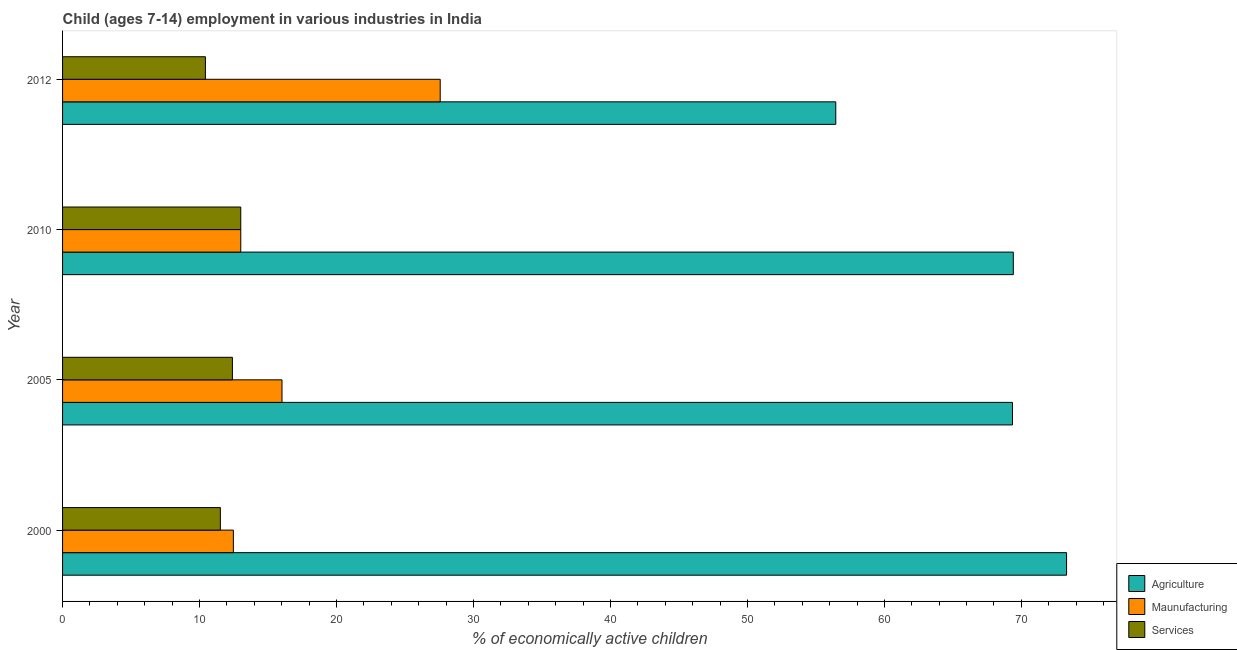Are the number of bars on each tick of the Y-axis equal?
Provide a short and direct response. Yes. How many bars are there on the 1st tick from the bottom?
Your answer should be compact. 3. What is the label of the 1st group of bars from the top?
Provide a short and direct response. 2012. In how many cases, is the number of bars for a given year not equal to the number of legend labels?
Provide a succinct answer. 0. What is the percentage of economically active children in manufacturing in 2010?
Provide a short and direct response. 13.01. Across all years, what is the maximum percentage of economically active children in services?
Offer a very short reply. 13.01. Across all years, what is the minimum percentage of economically active children in services?
Keep it short and to the point. 10.43. What is the total percentage of economically active children in agriculture in the graph?
Keep it short and to the point. 268.51. What is the difference between the percentage of economically active children in services in 2005 and that in 2010?
Provide a succinct answer. -0.61. What is the difference between the percentage of economically active children in agriculture in 2010 and the percentage of economically active children in manufacturing in 2005?
Offer a very short reply. 53.39. What is the average percentage of economically active children in services per year?
Ensure brevity in your answer.  11.84. In the year 2010, what is the difference between the percentage of economically active children in agriculture and percentage of economically active children in services?
Offer a very short reply. 56.4. In how many years, is the percentage of economically active children in manufacturing greater than 68 %?
Your response must be concise. 0. What is the ratio of the percentage of economically active children in manufacturing in 2000 to that in 2005?
Provide a succinct answer. 0.78. Is the difference between the percentage of economically active children in services in 2000 and 2012 greater than the difference between the percentage of economically active children in manufacturing in 2000 and 2012?
Offer a very short reply. Yes. What is the difference between the highest and the second highest percentage of economically active children in agriculture?
Your response must be concise. 3.89. What is the difference between the highest and the lowest percentage of economically active children in services?
Your response must be concise. 2.58. In how many years, is the percentage of economically active children in manufacturing greater than the average percentage of economically active children in manufacturing taken over all years?
Your answer should be very brief. 1. Is the sum of the percentage of economically active children in manufacturing in 2010 and 2012 greater than the maximum percentage of economically active children in agriculture across all years?
Keep it short and to the point. No. What does the 2nd bar from the top in 2000 represents?
Your response must be concise. Maunufacturing. What does the 3rd bar from the bottom in 2010 represents?
Your response must be concise. Services. Is it the case that in every year, the sum of the percentage of economically active children in agriculture and percentage of economically active children in manufacturing is greater than the percentage of economically active children in services?
Your response must be concise. Yes. How many bars are there?
Make the answer very short. 12. Does the graph contain any zero values?
Provide a short and direct response. No. Does the graph contain grids?
Offer a very short reply. No. Where does the legend appear in the graph?
Ensure brevity in your answer.  Bottom right. How are the legend labels stacked?
Provide a short and direct response. Vertical. What is the title of the graph?
Give a very brief answer. Child (ages 7-14) employment in various industries in India. Does "Social Protection" appear as one of the legend labels in the graph?
Give a very brief answer. No. What is the label or title of the X-axis?
Offer a terse response. % of economically active children. What is the % of economically active children in Agriculture in 2000?
Provide a succinct answer. 73.3. What is the % of economically active children in Maunufacturing in 2000?
Offer a very short reply. 12.47. What is the % of economically active children in Services in 2000?
Provide a short and direct response. 11.52. What is the % of economically active children of Agriculture in 2005?
Your answer should be very brief. 69.35. What is the % of economically active children of Maunufacturing in 2005?
Offer a very short reply. 16.02. What is the % of economically active children in Agriculture in 2010?
Your response must be concise. 69.41. What is the % of economically active children in Maunufacturing in 2010?
Your response must be concise. 13.01. What is the % of economically active children in Services in 2010?
Offer a very short reply. 13.01. What is the % of economically active children in Agriculture in 2012?
Ensure brevity in your answer.  56.45. What is the % of economically active children of Maunufacturing in 2012?
Provide a short and direct response. 27.57. What is the % of economically active children of Services in 2012?
Your response must be concise. 10.43. Across all years, what is the maximum % of economically active children of Agriculture?
Ensure brevity in your answer.  73.3. Across all years, what is the maximum % of economically active children of Maunufacturing?
Keep it short and to the point. 27.57. Across all years, what is the maximum % of economically active children of Services?
Offer a very short reply. 13.01. Across all years, what is the minimum % of economically active children in Agriculture?
Your response must be concise. 56.45. Across all years, what is the minimum % of economically active children of Maunufacturing?
Provide a short and direct response. 12.47. Across all years, what is the minimum % of economically active children of Services?
Your response must be concise. 10.43. What is the total % of economically active children in Agriculture in the graph?
Provide a short and direct response. 268.51. What is the total % of economically active children of Maunufacturing in the graph?
Your response must be concise. 69.07. What is the total % of economically active children of Services in the graph?
Your answer should be compact. 47.36. What is the difference between the % of economically active children in Agriculture in 2000 and that in 2005?
Your response must be concise. 3.95. What is the difference between the % of economically active children of Maunufacturing in 2000 and that in 2005?
Your answer should be compact. -3.55. What is the difference between the % of economically active children of Services in 2000 and that in 2005?
Keep it short and to the point. -0.88. What is the difference between the % of economically active children in Agriculture in 2000 and that in 2010?
Your response must be concise. 3.89. What is the difference between the % of economically active children of Maunufacturing in 2000 and that in 2010?
Your answer should be compact. -0.54. What is the difference between the % of economically active children of Services in 2000 and that in 2010?
Make the answer very short. -1.49. What is the difference between the % of economically active children in Agriculture in 2000 and that in 2012?
Your answer should be compact. 16.85. What is the difference between the % of economically active children in Maunufacturing in 2000 and that in 2012?
Give a very brief answer. -15.1. What is the difference between the % of economically active children in Services in 2000 and that in 2012?
Provide a short and direct response. 1.09. What is the difference between the % of economically active children of Agriculture in 2005 and that in 2010?
Provide a short and direct response. -0.06. What is the difference between the % of economically active children of Maunufacturing in 2005 and that in 2010?
Give a very brief answer. 3.01. What is the difference between the % of economically active children of Services in 2005 and that in 2010?
Make the answer very short. -0.61. What is the difference between the % of economically active children of Agriculture in 2005 and that in 2012?
Your answer should be very brief. 12.9. What is the difference between the % of economically active children in Maunufacturing in 2005 and that in 2012?
Provide a short and direct response. -11.55. What is the difference between the % of economically active children in Services in 2005 and that in 2012?
Your answer should be compact. 1.97. What is the difference between the % of economically active children in Agriculture in 2010 and that in 2012?
Offer a terse response. 12.96. What is the difference between the % of economically active children in Maunufacturing in 2010 and that in 2012?
Your answer should be compact. -14.56. What is the difference between the % of economically active children of Services in 2010 and that in 2012?
Give a very brief answer. 2.58. What is the difference between the % of economically active children of Agriculture in 2000 and the % of economically active children of Maunufacturing in 2005?
Provide a short and direct response. 57.28. What is the difference between the % of economically active children in Agriculture in 2000 and the % of economically active children in Services in 2005?
Make the answer very short. 60.9. What is the difference between the % of economically active children in Maunufacturing in 2000 and the % of economically active children in Services in 2005?
Make the answer very short. 0.07. What is the difference between the % of economically active children in Agriculture in 2000 and the % of economically active children in Maunufacturing in 2010?
Your answer should be compact. 60.29. What is the difference between the % of economically active children in Agriculture in 2000 and the % of economically active children in Services in 2010?
Give a very brief answer. 60.29. What is the difference between the % of economically active children of Maunufacturing in 2000 and the % of economically active children of Services in 2010?
Ensure brevity in your answer.  -0.54. What is the difference between the % of economically active children in Agriculture in 2000 and the % of economically active children in Maunufacturing in 2012?
Give a very brief answer. 45.73. What is the difference between the % of economically active children in Agriculture in 2000 and the % of economically active children in Services in 2012?
Provide a succinct answer. 62.87. What is the difference between the % of economically active children of Maunufacturing in 2000 and the % of economically active children of Services in 2012?
Offer a very short reply. 2.04. What is the difference between the % of economically active children in Agriculture in 2005 and the % of economically active children in Maunufacturing in 2010?
Your answer should be compact. 56.34. What is the difference between the % of economically active children of Agriculture in 2005 and the % of economically active children of Services in 2010?
Provide a succinct answer. 56.34. What is the difference between the % of economically active children of Maunufacturing in 2005 and the % of economically active children of Services in 2010?
Your response must be concise. 3.01. What is the difference between the % of economically active children in Agriculture in 2005 and the % of economically active children in Maunufacturing in 2012?
Your answer should be compact. 41.78. What is the difference between the % of economically active children of Agriculture in 2005 and the % of economically active children of Services in 2012?
Give a very brief answer. 58.92. What is the difference between the % of economically active children of Maunufacturing in 2005 and the % of economically active children of Services in 2012?
Offer a very short reply. 5.59. What is the difference between the % of economically active children in Agriculture in 2010 and the % of economically active children in Maunufacturing in 2012?
Keep it short and to the point. 41.84. What is the difference between the % of economically active children in Agriculture in 2010 and the % of economically active children in Services in 2012?
Give a very brief answer. 58.98. What is the difference between the % of economically active children of Maunufacturing in 2010 and the % of economically active children of Services in 2012?
Your answer should be compact. 2.58. What is the average % of economically active children of Agriculture per year?
Keep it short and to the point. 67.13. What is the average % of economically active children in Maunufacturing per year?
Offer a terse response. 17.27. What is the average % of economically active children of Services per year?
Provide a succinct answer. 11.84. In the year 2000, what is the difference between the % of economically active children of Agriculture and % of economically active children of Maunufacturing?
Offer a terse response. 60.83. In the year 2000, what is the difference between the % of economically active children in Agriculture and % of economically active children in Services?
Offer a very short reply. 61.78. In the year 2000, what is the difference between the % of economically active children of Maunufacturing and % of economically active children of Services?
Offer a terse response. 0.95. In the year 2005, what is the difference between the % of economically active children in Agriculture and % of economically active children in Maunufacturing?
Your answer should be very brief. 53.33. In the year 2005, what is the difference between the % of economically active children in Agriculture and % of economically active children in Services?
Offer a terse response. 56.95. In the year 2005, what is the difference between the % of economically active children of Maunufacturing and % of economically active children of Services?
Your response must be concise. 3.62. In the year 2010, what is the difference between the % of economically active children in Agriculture and % of economically active children in Maunufacturing?
Provide a succinct answer. 56.4. In the year 2010, what is the difference between the % of economically active children in Agriculture and % of economically active children in Services?
Make the answer very short. 56.4. In the year 2012, what is the difference between the % of economically active children in Agriculture and % of economically active children in Maunufacturing?
Offer a very short reply. 28.88. In the year 2012, what is the difference between the % of economically active children of Agriculture and % of economically active children of Services?
Your answer should be compact. 46.02. In the year 2012, what is the difference between the % of economically active children in Maunufacturing and % of economically active children in Services?
Keep it short and to the point. 17.14. What is the ratio of the % of economically active children of Agriculture in 2000 to that in 2005?
Your response must be concise. 1.06. What is the ratio of the % of economically active children in Maunufacturing in 2000 to that in 2005?
Your answer should be very brief. 0.78. What is the ratio of the % of economically active children of Services in 2000 to that in 2005?
Ensure brevity in your answer.  0.93. What is the ratio of the % of economically active children of Agriculture in 2000 to that in 2010?
Offer a very short reply. 1.06. What is the ratio of the % of economically active children in Maunufacturing in 2000 to that in 2010?
Your response must be concise. 0.96. What is the ratio of the % of economically active children in Services in 2000 to that in 2010?
Your answer should be compact. 0.89. What is the ratio of the % of economically active children in Agriculture in 2000 to that in 2012?
Offer a very short reply. 1.3. What is the ratio of the % of economically active children in Maunufacturing in 2000 to that in 2012?
Make the answer very short. 0.45. What is the ratio of the % of economically active children of Services in 2000 to that in 2012?
Ensure brevity in your answer.  1.1. What is the ratio of the % of economically active children of Agriculture in 2005 to that in 2010?
Make the answer very short. 1. What is the ratio of the % of economically active children in Maunufacturing in 2005 to that in 2010?
Make the answer very short. 1.23. What is the ratio of the % of economically active children in Services in 2005 to that in 2010?
Your answer should be very brief. 0.95. What is the ratio of the % of economically active children of Agriculture in 2005 to that in 2012?
Provide a succinct answer. 1.23. What is the ratio of the % of economically active children of Maunufacturing in 2005 to that in 2012?
Offer a terse response. 0.58. What is the ratio of the % of economically active children in Services in 2005 to that in 2012?
Provide a short and direct response. 1.19. What is the ratio of the % of economically active children in Agriculture in 2010 to that in 2012?
Offer a very short reply. 1.23. What is the ratio of the % of economically active children of Maunufacturing in 2010 to that in 2012?
Your answer should be compact. 0.47. What is the ratio of the % of economically active children of Services in 2010 to that in 2012?
Ensure brevity in your answer.  1.25. What is the difference between the highest and the second highest % of economically active children in Agriculture?
Offer a terse response. 3.89. What is the difference between the highest and the second highest % of economically active children of Maunufacturing?
Give a very brief answer. 11.55. What is the difference between the highest and the second highest % of economically active children in Services?
Keep it short and to the point. 0.61. What is the difference between the highest and the lowest % of economically active children in Agriculture?
Offer a very short reply. 16.85. What is the difference between the highest and the lowest % of economically active children of Services?
Keep it short and to the point. 2.58. 